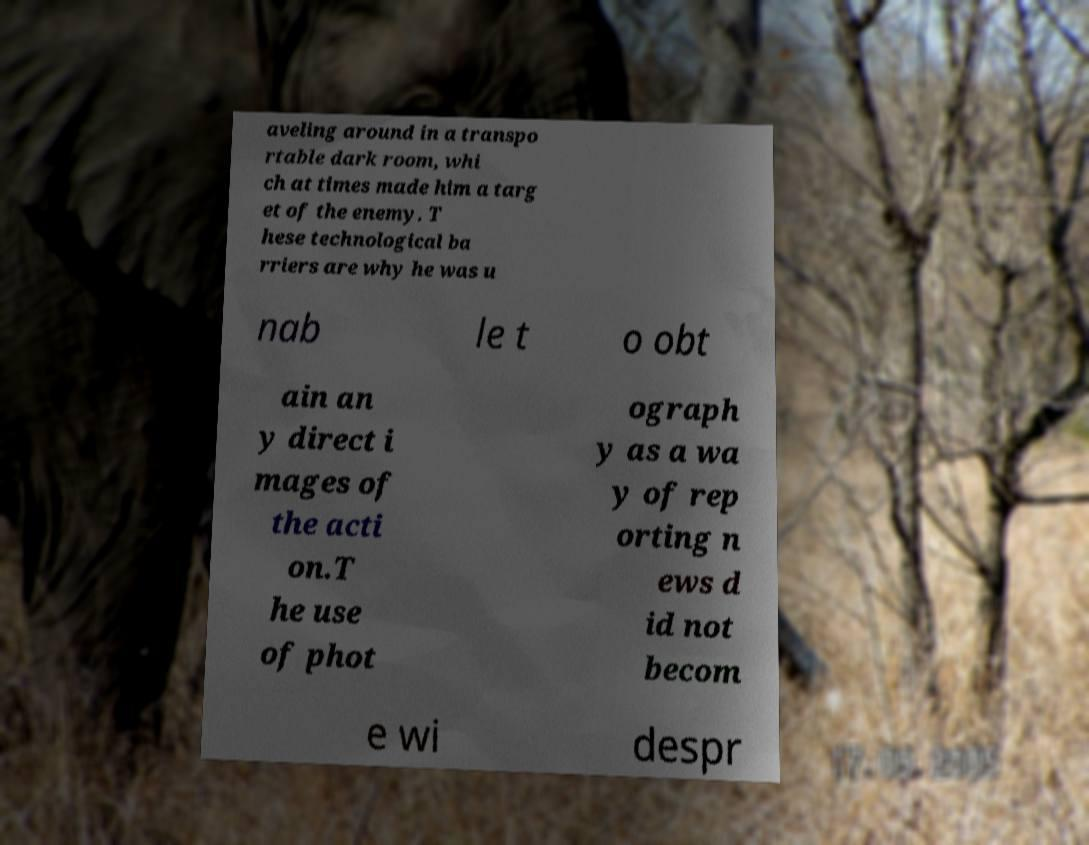Please read and relay the text visible in this image. What does it say? aveling around in a transpo rtable dark room, whi ch at times made him a targ et of the enemy. T hese technological ba rriers are why he was u nab le t o obt ain an y direct i mages of the acti on.T he use of phot ograph y as a wa y of rep orting n ews d id not becom e wi despr 